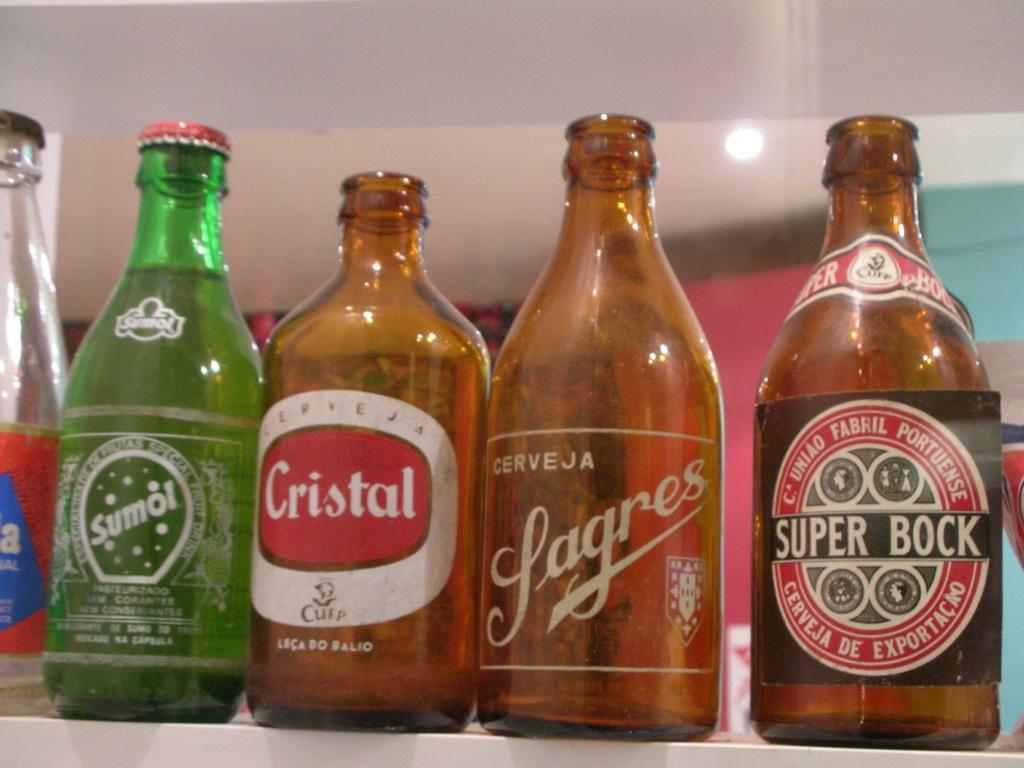What is the bottle on the right called?
Your answer should be very brief. Super bock. 